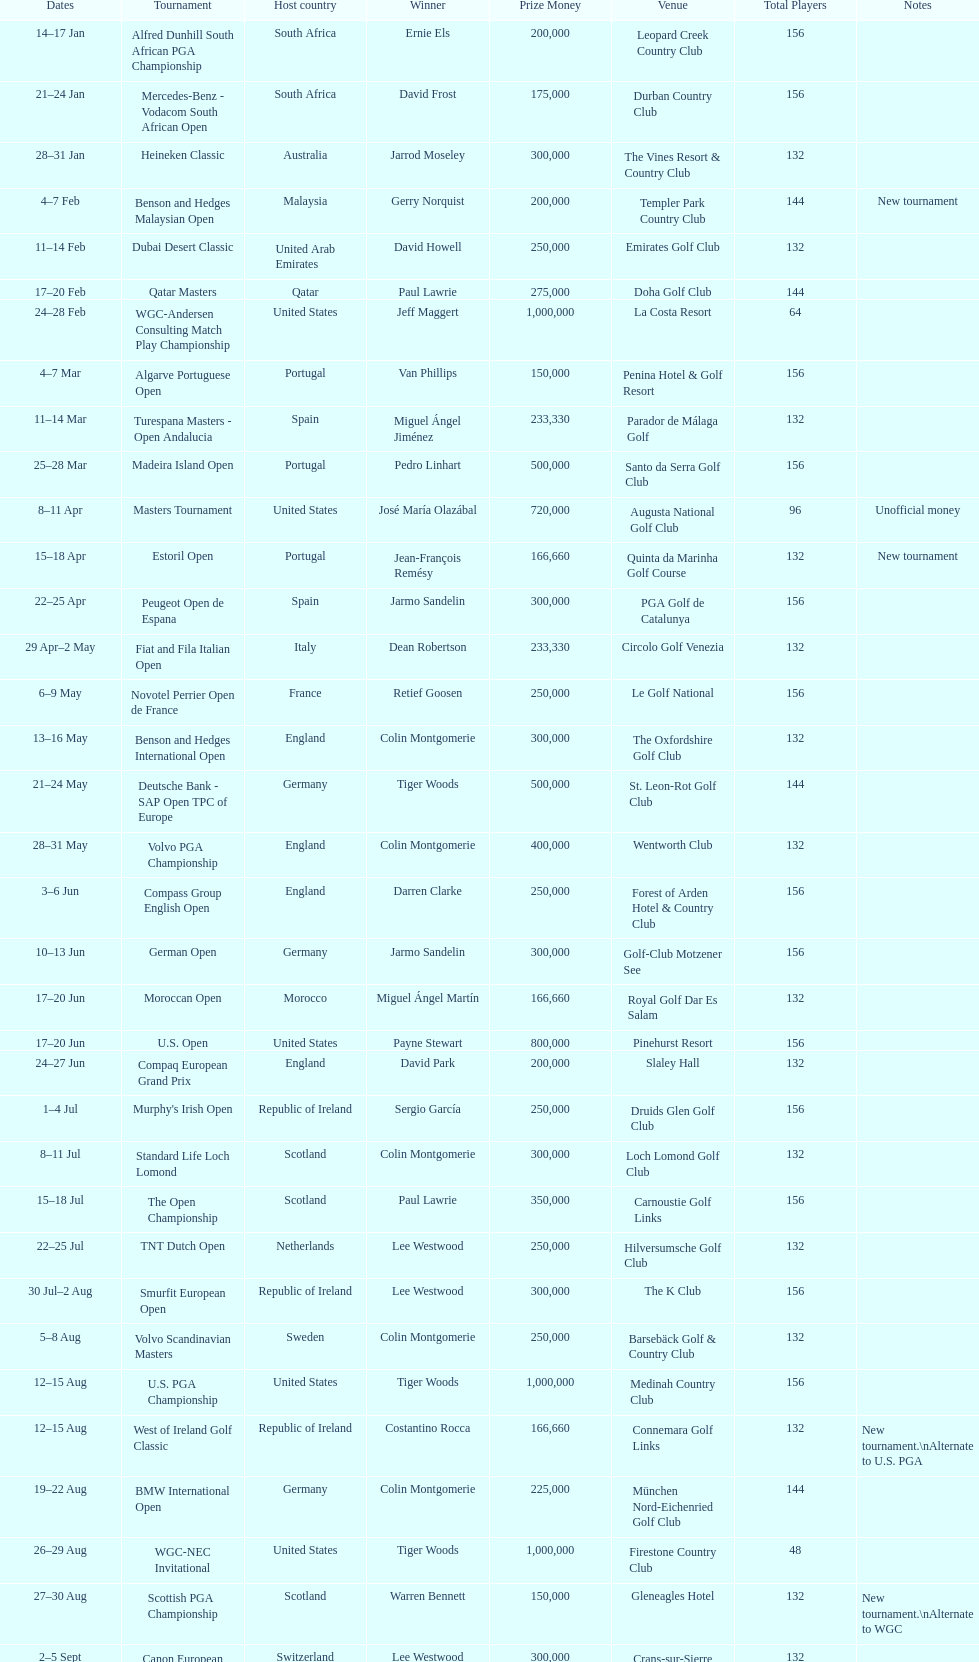Could you parse the entire table as a dict? {'header': ['Dates', 'Tournament', 'Host country', 'Winner', 'Prize Money', 'Venue', 'Total Players', 'Notes'], 'rows': [['14–17\xa0Jan', 'Alfred Dunhill South African PGA Championship', 'South Africa', 'Ernie Els', '200,000', 'Leopard Creek Country Club', '156', ''], ['21–24\xa0Jan', 'Mercedes-Benz - Vodacom South African Open', 'South Africa', 'David Frost', '175,000', 'Durban Country Club', '156', ''], ['28–31\xa0Jan', 'Heineken Classic', 'Australia', 'Jarrod Moseley', '300,000', 'The Vines Resort & Country Club', '132', ''], ['4–7\xa0Feb', 'Benson and Hedges Malaysian Open', 'Malaysia', 'Gerry Norquist', '200,000', 'Templer Park Country Club', '144', 'New tournament'], ['11–14\xa0Feb', 'Dubai Desert Classic', 'United Arab Emirates', 'David Howell', '250,000', 'Emirates Golf Club', '132', ''], ['17–20\xa0Feb', 'Qatar Masters', 'Qatar', 'Paul Lawrie', '275,000', 'Doha Golf Club', '144', ''], ['24–28\xa0Feb', 'WGC-Andersen Consulting Match Play Championship', 'United States', 'Jeff Maggert', '1,000,000', 'La Costa Resort', '64', ''], ['4–7\xa0Mar', 'Algarve Portuguese Open', 'Portugal', 'Van Phillips', '150,000', 'Penina Hotel & Golf Resort', '156', ''], ['11–14\xa0Mar', 'Turespana Masters - Open Andalucia', 'Spain', 'Miguel Ángel Jiménez', '233,330', 'Parador de Málaga Golf', '132', ''], ['25–28\xa0Mar', 'Madeira Island Open', 'Portugal', 'Pedro Linhart', '500,000', 'Santo da Serra Golf Club', '156', ''], ['8–11\xa0Apr', 'Masters Tournament', 'United States', 'José María Olazábal', '720,000', 'Augusta National Golf Club', '96', 'Unofficial money'], ['15–18\xa0Apr', 'Estoril Open', 'Portugal', 'Jean-François Remésy', '166,660', 'Quinta da Marinha Golf Course', '132', 'New tournament'], ['22–25\xa0Apr', 'Peugeot Open de Espana', 'Spain', 'Jarmo Sandelin', '300,000', 'PGA Golf de Catalunya', '156', ''], ['29\xa0Apr–2\xa0May', 'Fiat and Fila Italian Open', 'Italy', 'Dean Robertson', '233,330', 'Circolo Golf Venezia', '132', ''], ['6–9\xa0May', 'Novotel Perrier Open de France', 'France', 'Retief Goosen', '250,000', 'Le Golf National', '156', ''], ['13–16\xa0May', 'Benson and Hedges International Open', 'England', 'Colin Montgomerie', '300,000', 'The Oxfordshire Golf Club', '132', ''], ['21–24\xa0May', 'Deutsche Bank - SAP Open TPC of Europe', 'Germany', 'Tiger Woods', '500,000', 'St. Leon-Rot Golf Club', '144', ''], ['28–31\xa0May', 'Volvo PGA Championship', 'England', 'Colin Montgomerie', '400,000', 'Wentworth Club', '132', ''], ['3–6\xa0Jun', 'Compass Group English Open', 'England', 'Darren Clarke', '250,000', 'Forest of Arden Hotel & Country Club', '156', ''], ['10–13\xa0Jun', 'German Open', 'Germany', 'Jarmo Sandelin', '300,000', 'Golf-Club Motzener See', '156', ''], ['17–20\xa0Jun', 'Moroccan Open', 'Morocco', 'Miguel Ángel Martín', '166,660', 'Royal Golf Dar Es Salam', '132', ''], ['17–20\xa0Jun', 'U.S. Open', 'United States', 'Payne Stewart', '800,000', 'Pinehurst Resort', '156', ''], ['24–27\xa0Jun', 'Compaq European Grand Prix', 'England', 'David Park', '200,000', 'Slaley Hall', '132', ''], ['1–4\xa0Jul', "Murphy's Irish Open", 'Republic of Ireland', 'Sergio García', '250,000', 'Druids Glen Golf Club', '156', ''], ['8–11\xa0Jul', 'Standard Life Loch Lomond', 'Scotland', 'Colin Montgomerie', '300,000', 'Loch Lomond Golf Club', '132', ''], ['15–18\xa0Jul', 'The Open Championship', 'Scotland', 'Paul Lawrie', '350,000', 'Carnoustie Golf Links', '156', ''], ['22–25\xa0Jul', 'TNT Dutch Open', 'Netherlands', 'Lee Westwood', '250,000', 'Hilversumsche Golf Club', '132', ''], ['30\xa0Jul–2\xa0Aug', 'Smurfit European Open', 'Republic of Ireland', 'Lee Westwood', '300,000', 'The K Club', '156', ''], ['5–8\xa0Aug', 'Volvo Scandinavian Masters', 'Sweden', 'Colin Montgomerie', '250,000', 'Barsebäck Golf & Country Club', '132', ''], ['12–15\xa0Aug', 'U.S. PGA Championship', 'United States', 'Tiger Woods', '1,000,000', 'Medinah Country Club', '156', ''], ['12–15\xa0Aug', 'West of Ireland Golf Classic', 'Republic of Ireland', 'Costantino Rocca', '166,660', 'Connemara Golf Links', '132', 'New tournament.\\nAlternate to U.S. PGA'], ['19–22\xa0Aug', 'BMW International Open', 'Germany', 'Colin Montgomerie', '225,000', 'München Nord-Eichenried Golf Club', '144', ''], ['26–29\xa0Aug', 'WGC-NEC Invitational', 'United States', 'Tiger Woods', '1,000,000', 'Firestone Country Club', '48', ''], ['27–30\xa0Aug', 'Scottish PGA Championship', 'Scotland', 'Warren Bennett', '150,000', 'Gleneagles Hotel', '132', 'New tournament.\\nAlternate to WGC'], ['2–5\xa0Sept', 'Canon European Masters', 'Switzerland', 'Lee Westwood', '300,000', 'Crans-sur-Sierre Golf Club', '132', ''], ['9–12\xa0Sept', 'Victor Chandler British Masters', 'England', 'Bob May', '250,000', 'Woburn Golf Club', '156', ''], ['16–19\xa0Sept', 'Trophée Lancôme', 'France', 'Pierre Fulke', '180,000', 'Saint-Nom-la-Bretèche Golf Course', '144', ''], ['24–27\xa0Sept', 'Ryder Cup', 'United States', 'United States', '-', 'The Country Club', '24', 'Team event'], ['30\xa0Sept–3\xa0Oct', 'Linde German Masters', 'Germany', 'Sergio García', '400,000', 'Gut Kaden Golf Club', '132', ''], ['7–10\xa0Oct', 'Alfred Dunhill Cup', 'Scotland', 'Spain', '-', 'St. Andrews Links', '48', 'Team event.\\nUnofficial money'], ['14–17\xa0Oct', 'Cisco World Match Play Championship', 'England', 'Colin Montgomerie', '250,000', 'Wentworth Club', '12', 'Unofficial money'], ['14–17\xa0Oct', 'Sarazen World Open', 'Spain', 'Thomas Bjørn', '250,000', 'Golf de Pals', '132', 'New tournament'], ['21–24\xa0Oct', 'Belgacom Open', 'Belgium', 'Robert Karlsson', '166,660', 'Royal Zoute Golf Club', '132', ''], ['28–31\xa0Oct', 'Volvo Masters', 'Spain', 'Miguel Ángel Jiménez', '400,000', 'Montecastillo Golf & Sports Resort', '72', ''], ['4–7\xa0Nov', 'WGC-American Express Championship', 'Spain', 'Tiger Woods', '1,000,000', 'Valderrama Golf Club', '72', ''], ['18–21\xa0Nov', 'World Cup of Golf', 'Malaysia', 'United States', '-', 'Mines Resort & Golf Club', '48', 'Team event.\\nUnofficial money']]} Which tournament was later, volvo pga or algarve portuguese open? Volvo PGA. 